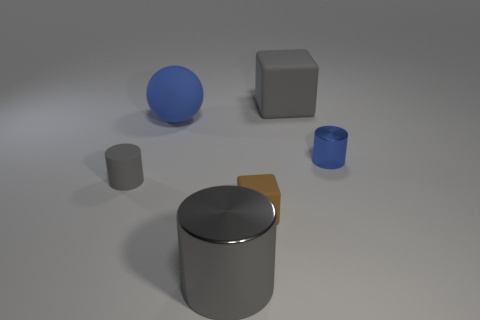How big is the rubber thing that is in front of the large blue rubber ball and on the right side of the large rubber ball?
Your answer should be compact. Small. What size is the object that is the same color as the rubber sphere?
Give a very brief answer. Small. What number of other things are there of the same size as the gray matte cylinder?
Your response must be concise. 2. There is a cylinder on the right side of the big gray rubber thing; what is it made of?
Make the answer very short. Metal. There is a blue thing that is on the left side of the gray thing that is behind the large thing to the left of the gray shiny cylinder; what is its shape?
Keep it short and to the point. Sphere. Is the size of the ball the same as the gray metal thing?
Ensure brevity in your answer.  Yes. What number of objects are either large things or cylinders to the right of the large blue thing?
Offer a very short reply. 4. What number of things are either objects right of the sphere or large gray things behind the large gray metal thing?
Offer a terse response. 4. Are there any blue matte objects behind the small blue thing?
Your answer should be compact. Yes. There is a shiny cylinder on the left side of the gray object that is right of the big cylinder that is in front of the small gray matte thing; what is its color?
Provide a succinct answer. Gray. 